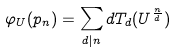<formula> <loc_0><loc_0><loc_500><loc_500>\varphi _ { U } ( p _ { n } ) = \sum _ { d | n } d T _ { d } ( U ^ { \frac { n } { d } } )</formula> 